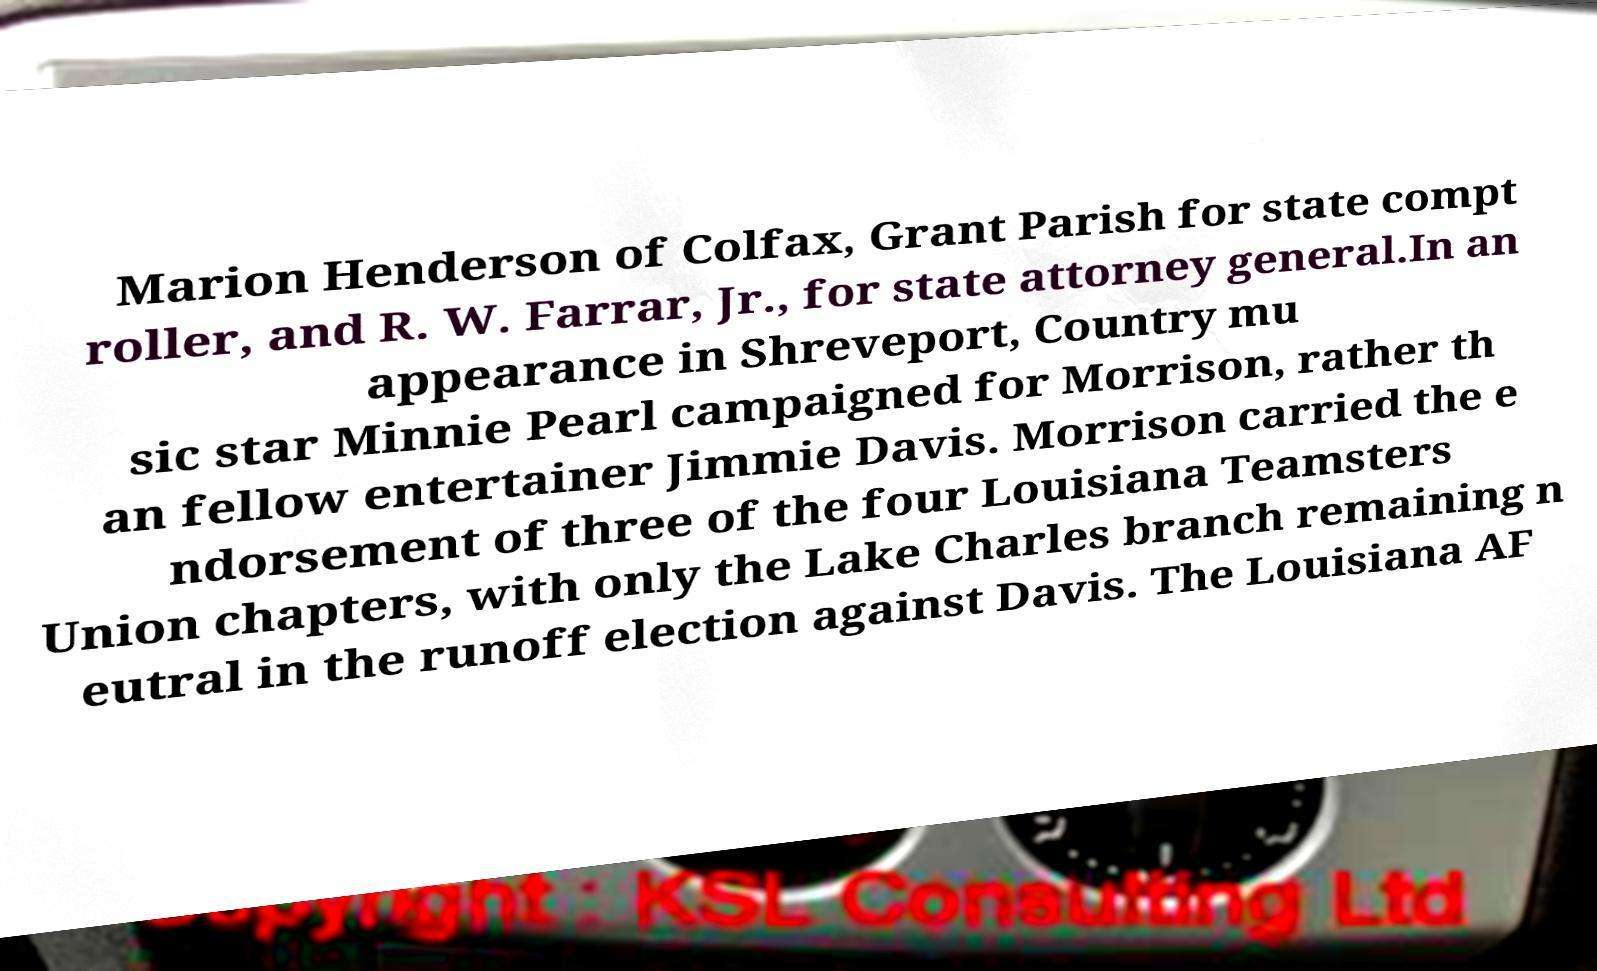Could you extract and type out the text from this image? Marion Henderson of Colfax, Grant Parish for state compt roller, and R. W. Farrar, Jr., for state attorney general.In an appearance in Shreveport, Country mu sic star Minnie Pearl campaigned for Morrison, rather th an fellow entertainer Jimmie Davis. Morrison carried the e ndorsement of three of the four Louisiana Teamsters Union chapters, with only the Lake Charles branch remaining n eutral in the runoff election against Davis. The Louisiana AF 